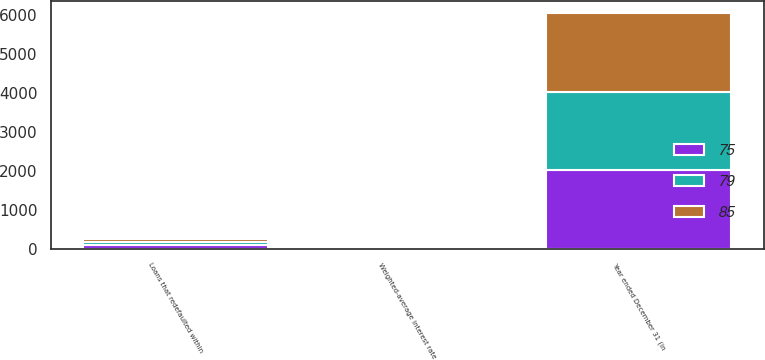Convert chart. <chart><loc_0><loc_0><loc_500><loc_500><stacked_bar_chart><ecel><fcel>Year ended December 31 (in<fcel>Weighted-average interest rate<fcel>Loans that redefaulted within<nl><fcel>85<fcel>2017<fcel>4.88<fcel>75<nl><fcel>79<fcel>2016<fcel>4.76<fcel>79<nl><fcel>75<fcel>2015<fcel>4.4<fcel>85<nl></chart> 